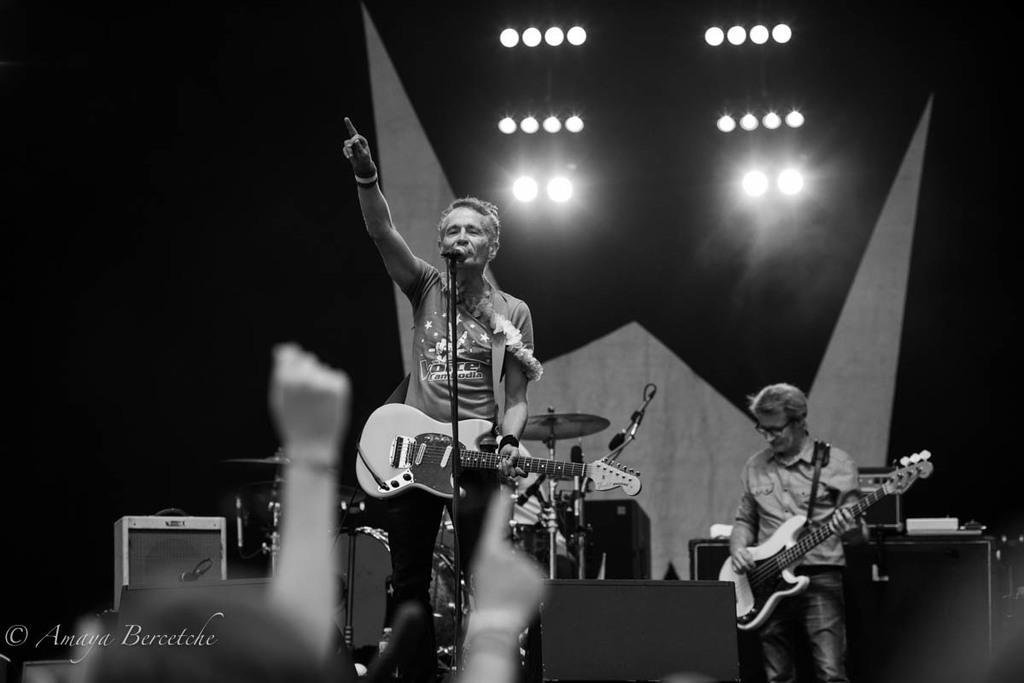Describe this image in one or two sentences. A person is singing, holding a guitar. In front of him there is a mic and mic stand. In the background another person is playing guitar. There are drums, cymbals. There are lights in the background. There are speakers in the front. 